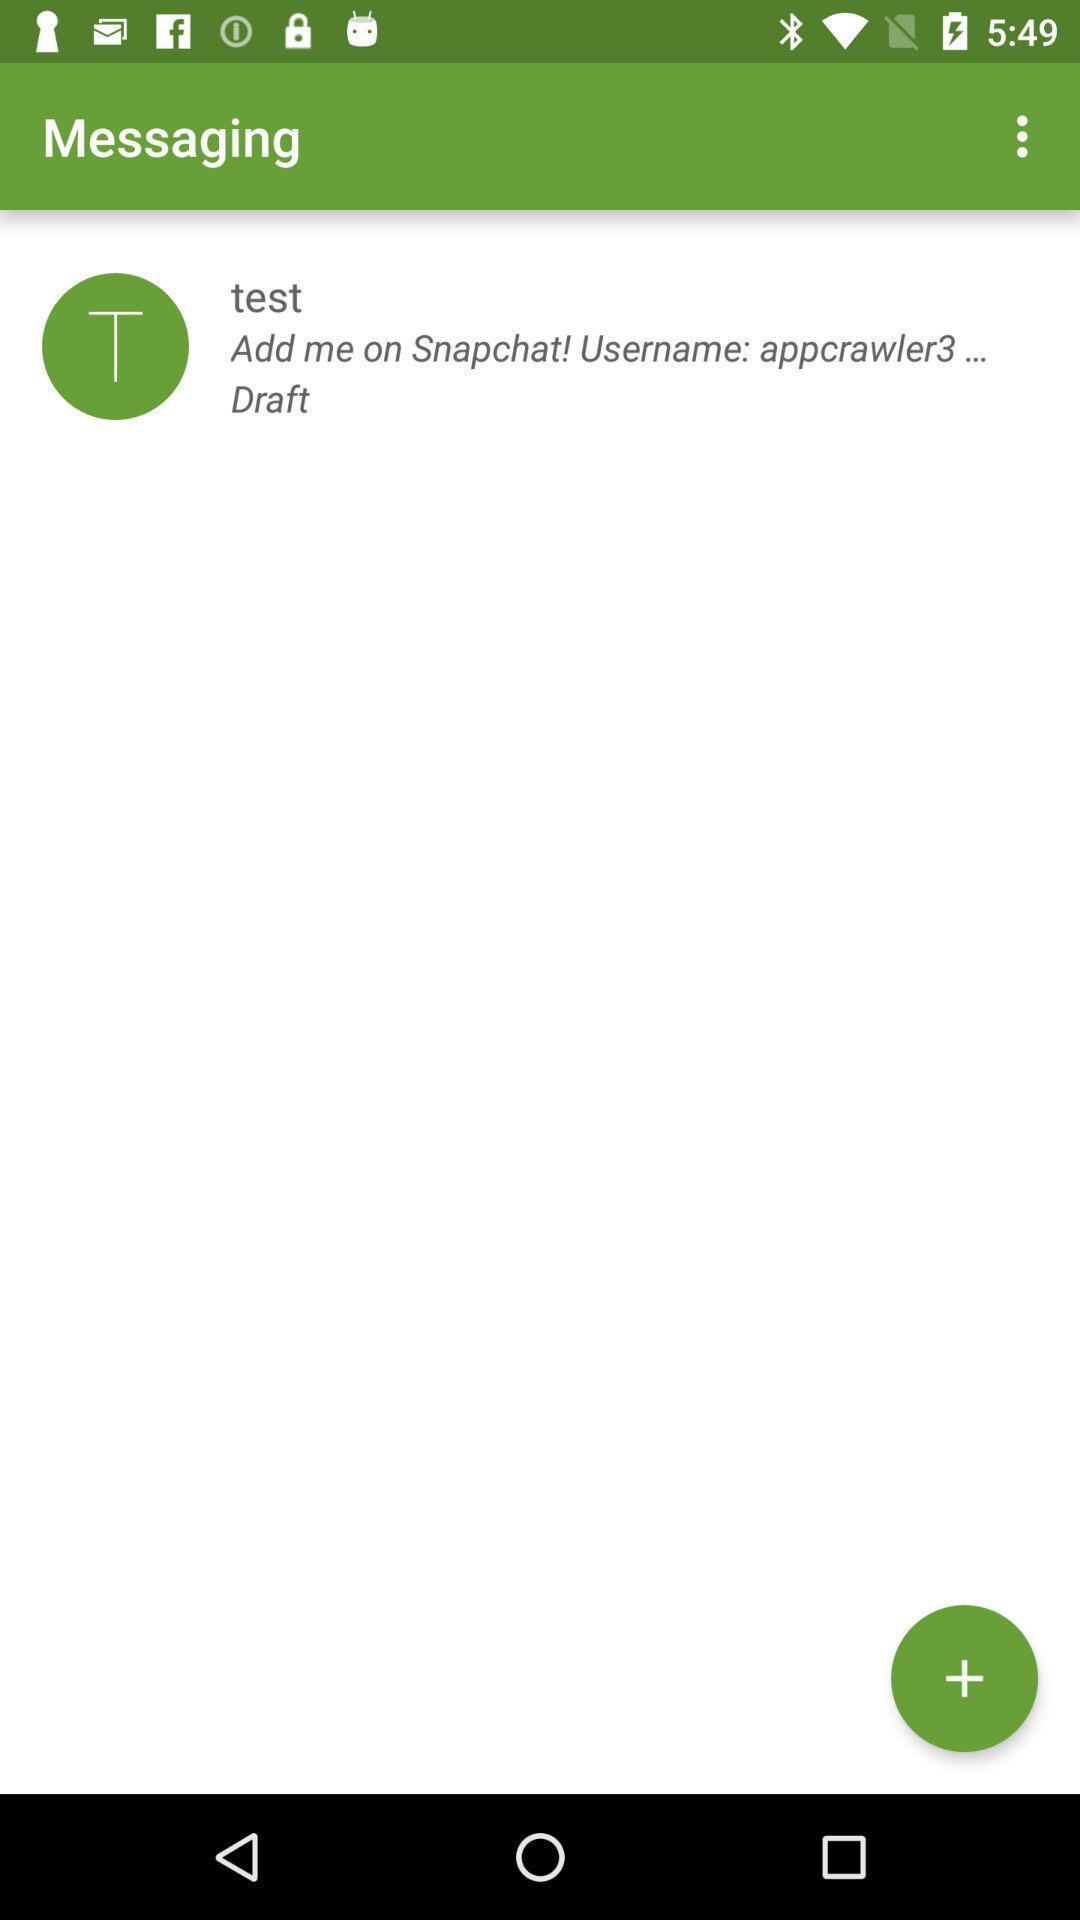Tell me what you see in this picture. Screen displaying messaging page. 